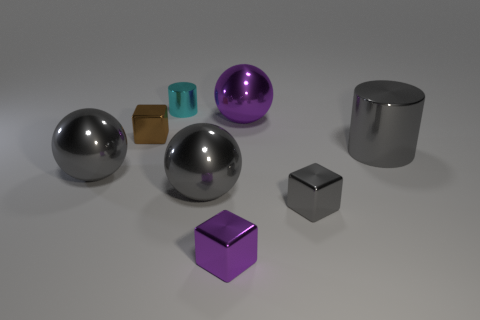Subtract all gray cylinders. How many gray balls are left? 2 Add 2 small red rubber blocks. How many objects exist? 10 Subtract all tiny gray cubes. How many cubes are left? 2 Subtract 1 cubes. How many cubes are left? 2 Subtract all large things. Subtract all blocks. How many objects are left? 1 Add 2 gray shiny balls. How many gray shiny balls are left? 4 Add 4 big objects. How many big objects exist? 8 Subtract 0 green spheres. How many objects are left? 8 Subtract all balls. How many objects are left? 5 Subtract all blue cubes. Subtract all purple spheres. How many cubes are left? 3 